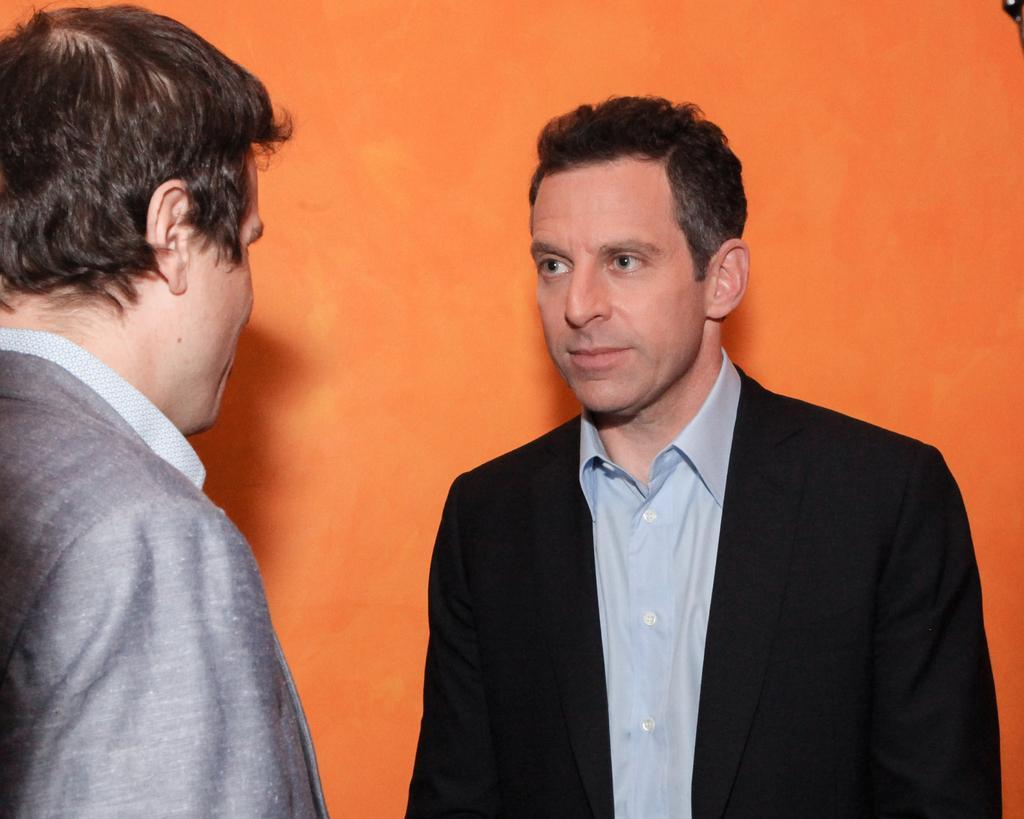In one or two sentences, can you explain what this image depicts? In the middle of the image there is a man. He has worn a suit and a shirt. In this image the background is orange in color. On the left side of the image there is a man. 